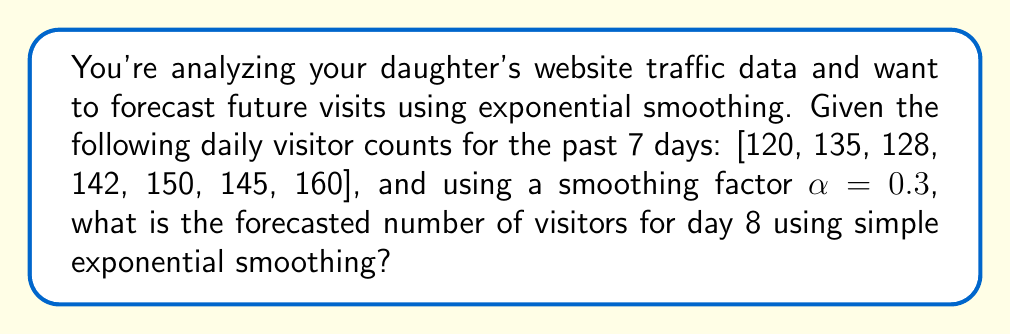Show me your answer to this math problem. To solve this problem, we'll use the simple exponential smoothing formula:

$$F_{t+1} = \alpha Y_t + (1-\alpha)F_t$$

Where:
$F_{t+1}$ is the forecast for the next period
$\alpha$ is the smoothing factor (0.3 in this case)
$Y_t$ is the actual value at time t
$F_t$ is the forecast for the current period

We'll start by initializing $F_1$ as the first observed value (120).

For day 2:
$$F_2 = 0.3 \cdot 120 + 0.7 \cdot 120 = 120$$

For day 3:
$$F_3 = 0.3 \cdot 135 + 0.7 \cdot 120 = 124.5$$

For day 4:
$$F_4 = 0.3 \cdot 128 + 0.7 \cdot 124.5 = 125.55$$

For day 5:
$$F_5 = 0.3 \cdot 142 + 0.7 \cdot 125.55 = 130.485$$

For day 6:
$$F_6 = 0.3 \cdot 150 + 0.7 \cdot 130.485 = 136.3395$$

For day 7:
$$F_7 = 0.3 \cdot 145 + 0.7 \cdot 136.3395 = 138.93765$$

Finally, for day 8 (our forecast):
$$F_8 = 0.3 \cdot 160 + 0.7 \cdot 138.93765 = 145.25636$$

Rounding to the nearest whole number, we get 145 visitors forecasted for day 8.
Answer: 145 visitors 